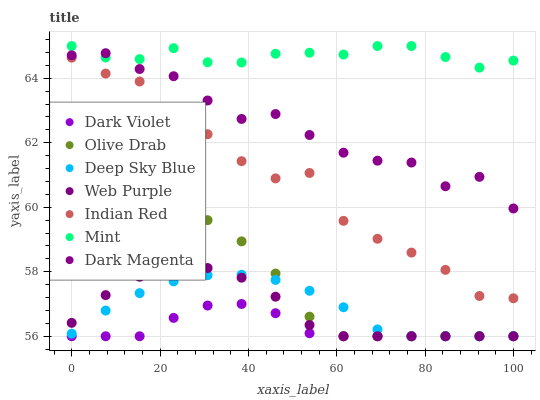Does Dark Violet have the minimum area under the curve?
Answer yes or no. Yes. Does Mint have the maximum area under the curve?
Answer yes or no. Yes. Does Web Purple have the minimum area under the curve?
Answer yes or no. No. Does Web Purple have the maximum area under the curve?
Answer yes or no. No. Is Deep Sky Blue the smoothest?
Answer yes or no. Yes. Is Indian Red the roughest?
Answer yes or no. Yes. Is Dark Violet the smoothest?
Answer yes or no. No. Is Dark Violet the roughest?
Answer yes or no. No. Does Deep Sky Blue have the lowest value?
Answer yes or no. Yes. Does Indian Red have the lowest value?
Answer yes or no. No. Does Mint have the highest value?
Answer yes or no. Yes. Does Web Purple have the highest value?
Answer yes or no. No. Is Olive Drab less than Indian Red?
Answer yes or no. Yes. Is Mint greater than Indian Red?
Answer yes or no. Yes. Does Web Purple intersect Olive Drab?
Answer yes or no. Yes. Is Web Purple less than Olive Drab?
Answer yes or no. No. Is Web Purple greater than Olive Drab?
Answer yes or no. No. Does Olive Drab intersect Indian Red?
Answer yes or no. No. 